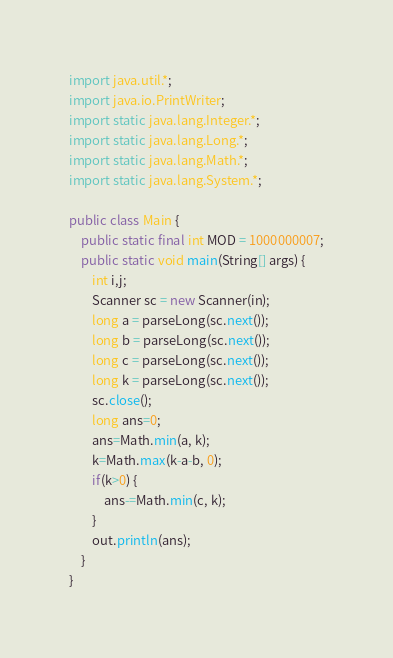<code> <loc_0><loc_0><loc_500><loc_500><_Java_>import java.util.*;
import java.io.PrintWriter;
import static java.lang.Integer.*;
import static java.lang.Long.*;
import static java.lang.Math.*;
import static java.lang.System.*;

public class Main {
	public static final int MOD = 1000000007;
	public static void main(String[] args) {
		int i,j;
		Scanner sc = new Scanner(in);
		long a = parseLong(sc.next());
		long b = parseLong(sc.next());
		long c = parseLong(sc.next());
		long k = parseLong(sc.next());
		sc.close();
		long ans=0;
		ans=Math.min(a, k);
		k=Math.max(k-a-b, 0);
		if(k>0) {
			ans-=Math.min(c, k);
		}
		out.println(ans);
	}
}
</code> 